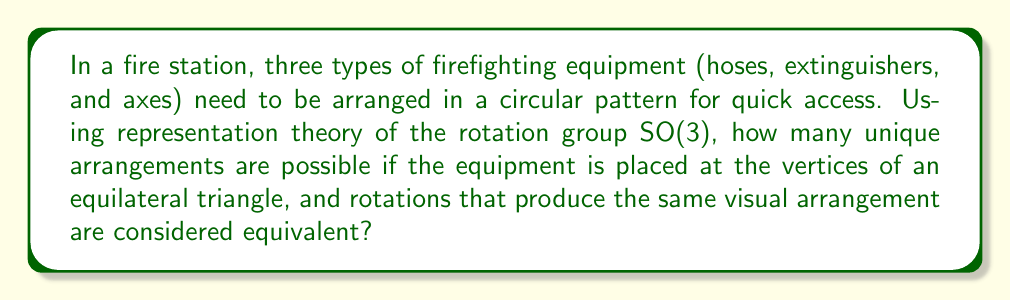Show me your answer to this math problem. Let's approach this step-by-step using representation theory:

1) The rotation group SO(3) acts on the equilateral triangle. The symmetry group of the triangle is a subgroup of SO(3), specifically the dihedral group D3.

2) We need to consider the action of D3 on the set of possible arrangements. There are 3! = 6 total ways to arrange 3 distinct objects.

3) The character table for D3 is:
   $$\begin{array}{c|ccc}
      & E & 2C_3 & 3\sigma_v \\
   \hline
   A_1 & 1 & 1 & 1 \\
   A_2 & 1 & 1 & -1 \\
   E   & 2 & -1 & 0
   \end{array}$$

4) The permutation representation P of D3 on the set of arrangements is reducible. We can decompose it as:
   $$P = A_1 \oplus E$$

5) The number of unique arrangements is given by the dimension of the invariant subspace, which corresponds to the number of times the trivial representation A1 appears in the decomposition.

6) From the decomposition, we see that A1 appears once.

Therefore, there is only one unique arrangement under the action of D3, which represents rotations that produce visually equivalent arrangements.
Answer: 1 unique arrangement 